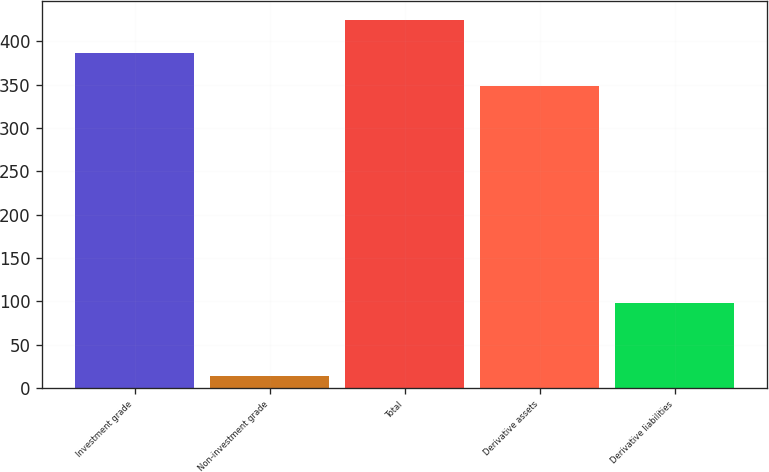Convert chart to OTSL. <chart><loc_0><loc_0><loc_500><loc_500><bar_chart><fcel>Investment grade<fcel>Non-investment grade<fcel>Total<fcel>Derivative assets<fcel>Derivative liabilities<nl><fcel>386.5<fcel>14<fcel>425<fcel>348<fcel>98<nl></chart> 